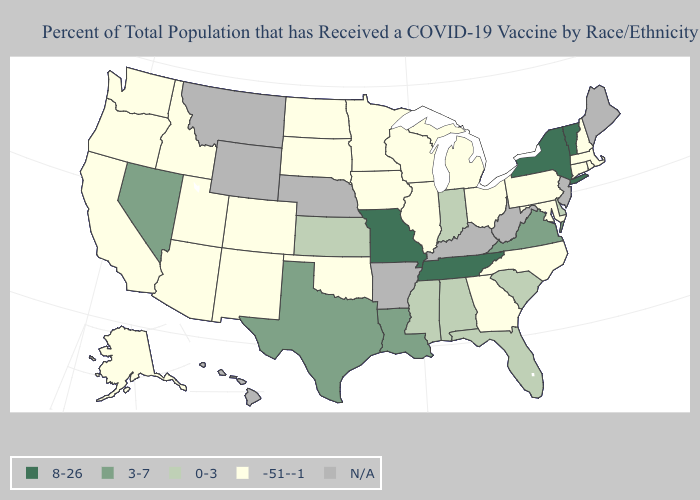Name the states that have a value in the range -51--1?
Write a very short answer. Alaska, Arizona, California, Colorado, Connecticut, Georgia, Idaho, Illinois, Iowa, Maryland, Massachusetts, Michigan, Minnesota, New Hampshire, New Mexico, North Carolina, North Dakota, Ohio, Oklahoma, Oregon, Pennsylvania, Rhode Island, South Dakota, Utah, Washington, Wisconsin. What is the lowest value in states that border Missouri?
Concise answer only. -51--1. Which states have the lowest value in the USA?
Quick response, please. Alaska, Arizona, California, Colorado, Connecticut, Georgia, Idaho, Illinois, Iowa, Maryland, Massachusetts, Michigan, Minnesota, New Hampshire, New Mexico, North Carolina, North Dakota, Ohio, Oklahoma, Oregon, Pennsylvania, Rhode Island, South Dakota, Utah, Washington, Wisconsin. What is the value of South Dakota?
Give a very brief answer. -51--1. Does the map have missing data?
Keep it brief. Yes. What is the value of North Carolina?
Give a very brief answer. -51--1. Which states have the lowest value in the MidWest?
Be succinct. Illinois, Iowa, Michigan, Minnesota, North Dakota, Ohio, South Dakota, Wisconsin. What is the lowest value in the MidWest?
Keep it brief. -51--1. Among the states that border Kansas , does Missouri have the highest value?
Quick response, please. Yes. What is the value of Louisiana?
Write a very short answer. 3-7. What is the value of Maryland?
Quick response, please. -51--1. Does the first symbol in the legend represent the smallest category?
Answer briefly. No. Which states have the lowest value in the South?
Answer briefly. Georgia, Maryland, North Carolina, Oklahoma. How many symbols are there in the legend?
Quick response, please. 5. 